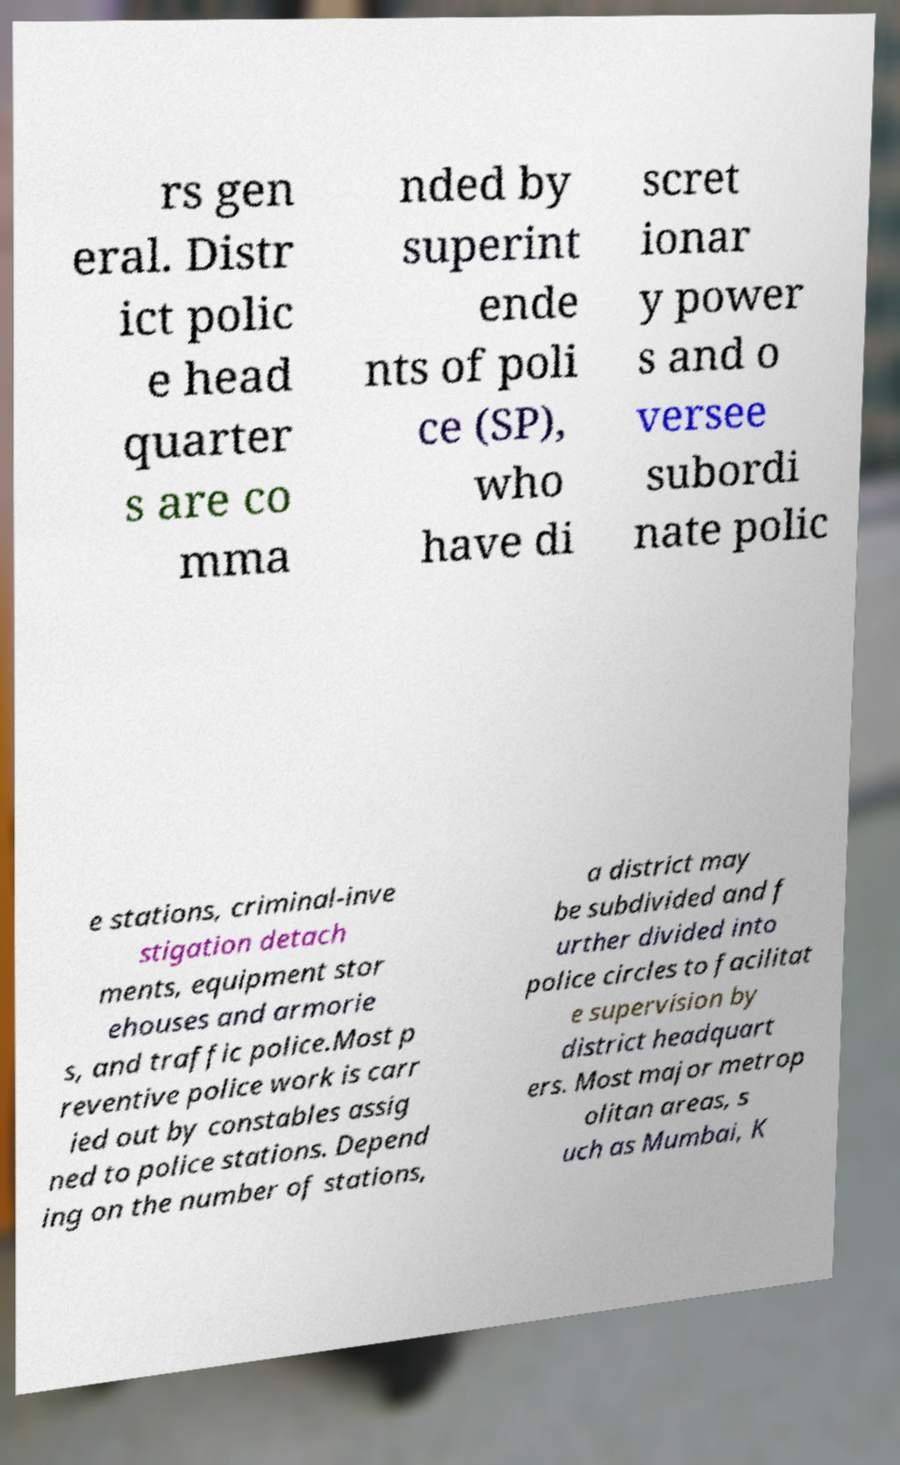Please read and relay the text visible in this image. What does it say? rs gen eral. Distr ict polic e head quarter s are co mma nded by superint ende nts of poli ce (SP), who have di scret ionar y power s and o versee subordi nate polic e stations, criminal-inve stigation detach ments, equipment stor ehouses and armorie s, and traffic police.Most p reventive police work is carr ied out by constables assig ned to police stations. Depend ing on the number of stations, a district may be subdivided and f urther divided into police circles to facilitat e supervision by district headquart ers. Most major metrop olitan areas, s uch as Mumbai, K 